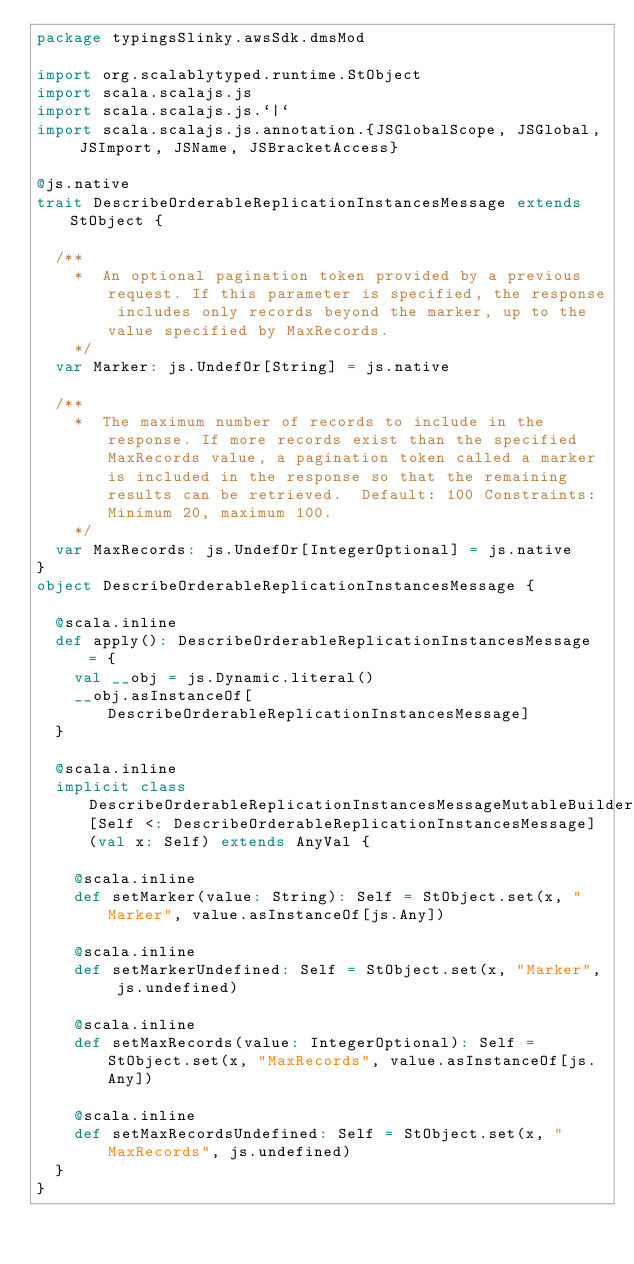Convert code to text. <code><loc_0><loc_0><loc_500><loc_500><_Scala_>package typingsSlinky.awsSdk.dmsMod

import org.scalablytyped.runtime.StObject
import scala.scalajs.js
import scala.scalajs.js.`|`
import scala.scalajs.js.annotation.{JSGlobalScope, JSGlobal, JSImport, JSName, JSBracketAccess}

@js.native
trait DescribeOrderableReplicationInstancesMessage extends StObject {
  
  /**
    *  An optional pagination token provided by a previous request. If this parameter is specified, the response includes only records beyond the marker, up to the value specified by MaxRecords. 
    */
  var Marker: js.UndefOr[String] = js.native
  
  /**
    *  The maximum number of records to include in the response. If more records exist than the specified MaxRecords value, a pagination token called a marker is included in the response so that the remaining results can be retrieved.  Default: 100 Constraints: Minimum 20, maximum 100.
    */
  var MaxRecords: js.UndefOr[IntegerOptional] = js.native
}
object DescribeOrderableReplicationInstancesMessage {
  
  @scala.inline
  def apply(): DescribeOrderableReplicationInstancesMessage = {
    val __obj = js.Dynamic.literal()
    __obj.asInstanceOf[DescribeOrderableReplicationInstancesMessage]
  }
  
  @scala.inline
  implicit class DescribeOrderableReplicationInstancesMessageMutableBuilder[Self <: DescribeOrderableReplicationInstancesMessage] (val x: Self) extends AnyVal {
    
    @scala.inline
    def setMarker(value: String): Self = StObject.set(x, "Marker", value.asInstanceOf[js.Any])
    
    @scala.inline
    def setMarkerUndefined: Self = StObject.set(x, "Marker", js.undefined)
    
    @scala.inline
    def setMaxRecords(value: IntegerOptional): Self = StObject.set(x, "MaxRecords", value.asInstanceOf[js.Any])
    
    @scala.inline
    def setMaxRecordsUndefined: Self = StObject.set(x, "MaxRecords", js.undefined)
  }
}
</code> 